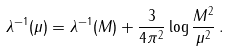Convert formula to latex. <formula><loc_0><loc_0><loc_500><loc_500>\lambda ^ { - 1 } ( \mu ) = \lambda ^ { - 1 } ( M ) + \frac { 3 } { 4 \pi ^ { 2 } } \log \frac { M ^ { 2 } } { \mu ^ { 2 } } \, .</formula> 